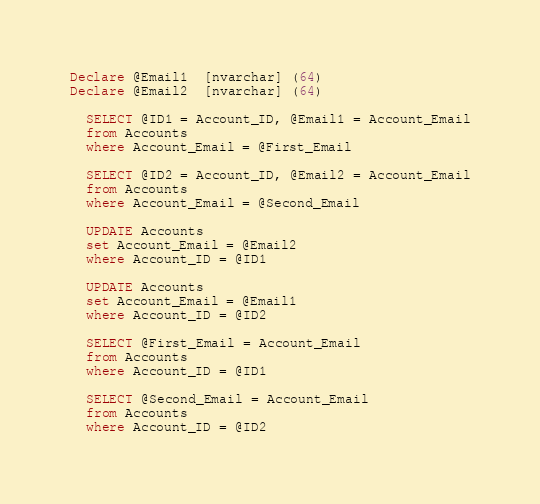<code> <loc_0><loc_0><loc_500><loc_500><_SQL_>
Declare @Email1  [nvarchar] (64)
Declare @Email2  [nvarchar] (64)

  SELECT @ID1 = Account_ID, @Email1 = Account_Email
  from Accounts
  where Account_Email = @First_Email

  SELECT @ID2 = Account_ID, @Email2 = Account_Email
  from Accounts
  where Account_Email = @Second_Email

  UPDATE Accounts
  set Account_Email = @Email2
  where Account_ID = @ID1

  UPDATE Accounts
  set Account_Email = @Email1
  where Account_ID = @ID2

  SELECT @First_Email = Account_Email
  from Accounts
  where Account_ID = @ID1

  SELECT @Second_Email = Account_Email
  from Accounts
  where Account_ID = @ID2
</code> 